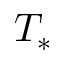<formula> <loc_0><loc_0><loc_500><loc_500>T _ { * }</formula> 